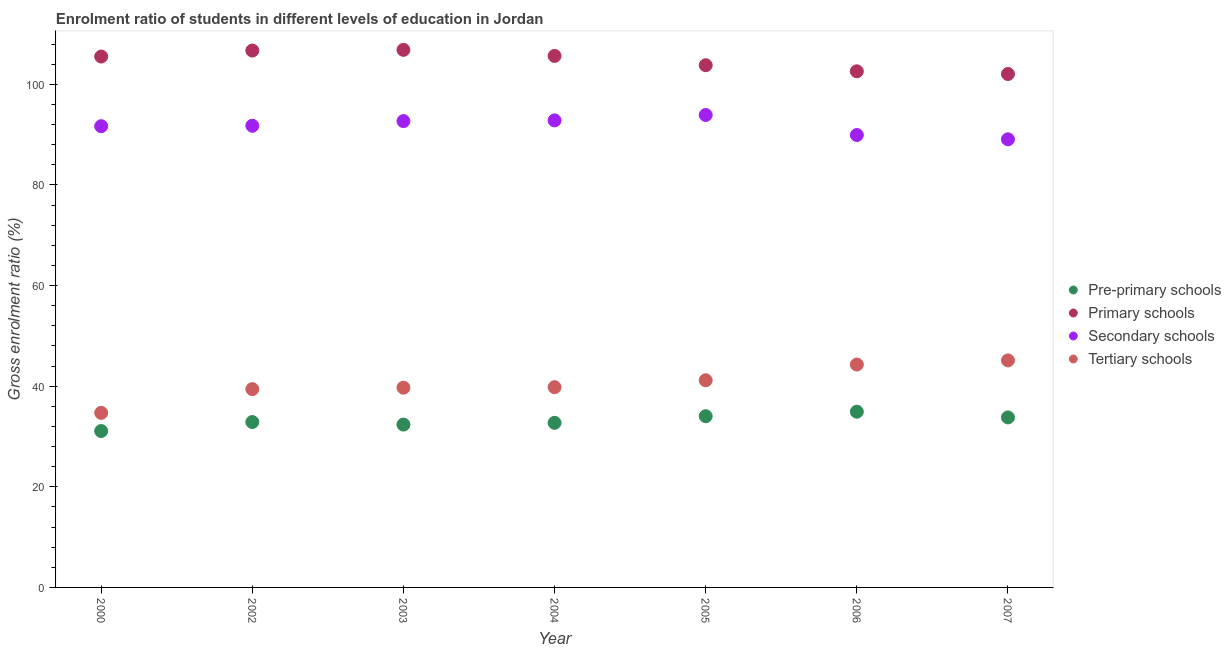How many different coloured dotlines are there?
Your answer should be very brief. 4. Is the number of dotlines equal to the number of legend labels?
Your answer should be compact. Yes. What is the gross enrolment ratio in primary schools in 2003?
Your answer should be compact. 106.83. Across all years, what is the maximum gross enrolment ratio in secondary schools?
Provide a short and direct response. 93.89. Across all years, what is the minimum gross enrolment ratio in secondary schools?
Your answer should be very brief. 89.06. In which year was the gross enrolment ratio in secondary schools maximum?
Provide a succinct answer. 2005. In which year was the gross enrolment ratio in secondary schools minimum?
Give a very brief answer. 2007. What is the total gross enrolment ratio in secondary schools in the graph?
Your response must be concise. 641.78. What is the difference between the gross enrolment ratio in pre-primary schools in 2002 and that in 2007?
Offer a terse response. -0.92. What is the difference between the gross enrolment ratio in tertiary schools in 2003 and the gross enrolment ratio in secondary schools in 2000?
Ensure brevity in your answer.  -51.97. What is the average gross enrolment ratio in pre-primary schools per year?
Keep it short and to the point. 33.11. In the year 2004, what is the difference between the gross enrolment ratio in pre-primary schools and gross enrolment ratio in primary schools?
Give a very brief answer. -72.92. In how many years, is the gross enrolment ratio in primary schools greater than 104 %?
Make the answer very short. 4. What is the ratio of the gross enrolment ratio in secondary schools in 2000 to that in 2007?
Offer a very short reply. 1.03. Is the gross enrolment ratio in primary schools in 2003 less than that in 2007?
Your answer should be very brief. No. Is the difference between the gross enrolment ratio in primary schools in 2000 and 2007 greater than the difference between the gross enrolment ratio in secondary schools in 2000 and 2007?
Offer a terse response. Yes. What is the difference between the highest and the second highest gross enrolment ratio in secondary schools?
Provide a short and direct response. 1.07. What is the difference between the highest and the lowest gross enrolment ratio in pre-primary schools?
Your answer should be very brief. 3.84. In how many years, is the gross enrolment ratio in primary schools greater than the average gross enrolment ratio in primary schools taken over all years?
Your answer should be very brief. 4. Is the sum of the gross enrolment ratio in pre-primary schools in 2003 and 2006 greater than the maximum gross enrolment ratio in secondary schools across all years?
Ensure brevity in your answer.  No. Is it the case that in every year, the sum of the gross enrolment ratio in pre-primary schools and gross enrolment ratio in primary schools is greater than the gross enrolment ratio in secondary schools?
Provide a short and direct response. Yes. Is the gross enrolment ratio in primary schools strictly less than the gross enrolment ratio in pre-primary schools over the years?
Your response must be concise. No. What is the difference between two consecutive major ticks on the Y-axis?
Your response must be concise. 20. Are the values on the major ticks of Y-axis written in scientific E-notation?
Keep it short and to the point. No. Does the graph contain any zero values?
Provide a succinct answer. No. How many legend labels are there?
Give a very brief answer. 4. How are the legend labels stacked?
Your answer should be very brief. Vertical. What is the title of the graph?
Ensure brevity in your answer.  Enrolment ratio of students in different levels of education in Jordan. Does "Agricultural land" appear as one of the legend labels in the graph?
Offer a terse response. No. What is the label or title of the Y-axis?
Give a very brief answer. Gross enrolment ratio (%). What is the Gross enrolment ratio (%) in Pre-primary schools in 2000?
Your response must be concise. 31.08. What is the Gross enrolment ratio (%) of Primary schools in 2000?
Your answer should be very brief. 105.51. What is the Gross enrolment ratio (%) in Secondary schools in 2000?
Keep it short and to the point. 91.67. What is the Gross enrolment ratio (%) of Tertiary schools in 2000?
Your answer should be very brief. 34.69. What is the Gross enrolment ratio (%) in Pre-primary schools in 2002?
Provide a succinct answer. 32.87. What is the Gross enrolment ratio (%) in Primary schools in 2002?
Provide a short and direct response. 106.7. What is the Gross enrolment ratio (%) of Secondary schools in 2002?
Provide a short and direct response. 91.75. What is the Gross enrolment ratio (%) in Tertiary schools in 2002?
Keep it short and to the point. 39.41. What is the Gross enrolment ratio (%) of Pre-primary schools in 2003?
Keep it short and to the point. 32.37. What is the Gross enrolment ratio (%) of Primary schools in 2003?
Offer a very short reply. 106.83. What is the Gross enrolment ratio (%) of Secondary schools in 2003?
Keep it short and to the point. 92.68. What is the Gross enrolment ratio (%) in Tertiary schools in 2003?
Offer a terse response. 39.7. What is the Gross enrolment ratio (%) in Pre-primary schools in 2004?
Ensure brevity in your answer.  32.71. What is the Gross enrolment ratio (%) of Primary schools in 2004?
Ensure brevity in your answer.  105.63. What is the Gross enrolment ratio (%) in Secondary schools in 2004?
Make the answer very short. 92.82. What is the Gross enrolment ratio (%) of Tertiary schools in 2004?
Make the answer very short. 39.8. What is the Gross enrolment ratio (%) in Pre-primary schools in 2005?
Make the answer very short. 34.03. What is the Gross enrolment ratio (%) of Primary schools in 2005?
Make the answer very short. 103.79. What is the Gross enrolment ratio (%) of Secondary schools in 2005?
Give a very brief answer. 93.89. What is the Gross enrolment ratio (%) in Tertiary schools in 2005?
Ensure brevity in your answer.  41.17. What is the Gross enrolment ratio (%) of Pre-primary schools in 2006?
Provide a succinct answer. 34.92. What is the Gross enrolment ratio (%) in Primary schools in 2006?
Provide a succinct answer. 102.57. What is the Gross enrolment ratio (%) of Secondary schools in 2006?
Your answer should be very brief. 89.91. What is the Gross enrolment ratio (%) in Tertiary schools in 2006?
Give a very brief answer. 44.3. What is the Gross enrolment ratio (%) of Pre-primary schools in 2007?
Your response must be concise. 33.78. What is the Gross enrolment ratio (%) in Primary schools in 2007?
Provide a succinct answer. 102.04. What is the Gross enrolment ratio (%) in Secondary schools in 2007?
Provide a succinct answer. 89.06. What is the Gross enrolment ratio (%) in Tertiary schools in 2007?
Your answer should be compact. 45.12. Across all years, what is the maximum Gross enrolment ratio (%) of Pre-primary schools?
Your response must be concise. 34.92. Across all years, what is the maximum Gross enrolment ratio (%) in Primary schools?
Your answer should be very brief. 106.83. Across all years, what is the maximum Gross enrolment ratio (%) in Secondary schools?
Your answer should be compact. 93.89. Across all years, what is the maximum Gross enrolment ratio (%) in Tertiary schools?
Provide a short and direct response. 45.12. Across all years, what is the minimum Gross enrolment ratio (%) in Pre-primary schools?
Give a very brief answer. 31.08. Across all years, what is the minimum Gross enrolment ratio (%) in Primary schools?
Give a very brief answer. 102.04. Across all years, what is the minimum Gross enrolment ratio (%) of Secondary schools?
Offer a terse response. 89.06. Across all years, what is the minimum Gross enrolment ratio (%) in Tertiary schools?
Provide a succinct answer. 34.69. What is the total Gross enrolment ratio (%) of Pre-primary schools in the graph?
Your answer should be very brief. 231.76. What is the total Gross enrolment ratio (%) in Primary schools in the graph?
Provide a succinct answer. 733.08. What is the total Gross enrolment ratio (%) in Secondary schools in the graph?
Give a very brief answer. 641.78. What is the total Gross enrolment ratio (%) in Tertiary schools in the graph?
Provide a succinct answer. 284.19. What is the difference between the Gross enrolment ratio (%) in Pre-primary schools in 2000 and that in 2002?
Provide a short and direct response. -1.79. What is the difference between the Gross enrolment ratio (%) in Primary schools in 2000 and that in 2002?
Ensure brevity in your answer.  -1.19. What is the difference between the Gross enrolment ratio (%) of Secondary schools in 2000 and that in 2002?
Provide a short and direct response. -0.09. What is the difference between the Gross enrolment ratio (%) of Tertiary schools in 2000 and that in 2002?
Offer a very short reply. -4.72. What is the difference between the Gross enrolment ratio (%) in Pre-primary schools in 2000 and that in 2003?
Offer a very short reply. -1.29. What is the difference between the Gross enrolment ratio (%) of Primary schools in 2000 and that in 2003?
Your answer should be very brief. -1.32. What is the difference between the Gross enrolment ratio (%) in Secondary schools in 2000 and that in 2003?
Keep it short and to the point. -1.01. What is the difference between the Gross enrolment ratio (%) of Tertiary schools in 2000 and that in 2003?
Give a very brief answer. -5. What is the difference between the Gross enrolment ratio (%) of Pre-primary schools in 2000 and that in 2004?
Offer a very short reply. -1.63. What is the difference between the Gross enrolment ratio (%) of Primary schools in 2000 and that in 2004?
Keep it short and to the point. -0.12. What is the difference between the Gross enrolment ratio (%) of Secondary schools in 2000 and that in 2004?
Give a very brief answer. -1.15. What is the difference between the Gross enrolment ratio (%) in Tertiary schools in 2000 and that in 2004?
Ensure brevity in your answer.  -5.1. What is the difference between the Gross enrolment ratio (%) in Pre-primary schools in 2000 and that in 2005?
Provide a succinct answer. -2.95. What is the difference between the Gross enrolment ratio (%) of Primary schools in 2000 and that in 2005?
Offer a very short reply. 1.72. What is the difference between the Gross enrolment ratio (%) of Secondary schools in 2000 and that in 2005?
Keep it short and to the point. -2.23. What is the difference between the Gross enrolment ratio (%) in Tertiary schools in 2000 and that in 2005?
Offer a very short reply. -6.47. What is the difference between the Gross enrolment ratio (%) of Pre-primary schools in 2000 and that in 2006?
Provide a short and direct response. -3.84. What is the difference between the Gross enrolment ratio (%) in Primary schools in 2000 and that in 2006?
Make the answer very short. 2.94. What is the difference between the Gross enrolment ratio (%) in Secondary schools in 2000 and that in 2006?
Offer a very short reply. 1.76. What is the difference between the Gross enrolment ratio (%) in Tertiary schools in 2000 and that in 2006?
Provide a succinct answer. -9.61. What is the difference between the Gross enrolment ratio (%) of Pre-primary schools in 2000 and that in 2007?
Your response must be concise. -2.7. What is the difference between the Gross enrolment ratio (%) in Primary schools in 2000 and that in 2007?
Provide a short and direct response. 3.47. What is the difference between the Gross enrolment ratio (%) in Secondary schools in 2000 and that in 2007?
Ensure brevity in your answer.  2.61. What is the difference between the Gross enrolment ratio (%) in Tertiary schools in 2000 and that in 2007?
Keep it short and to the point. -10.43. What is the difference between the Gross enrolment ratio (%) of Pre-primary schools in 2002 and that in 2003?
Keep it short and to the point. 0.5. What is the difference between the Gross enrolment ratio (%) in Primary schools in 2002 and that in 2003?
Give a very brief answer. -0.13. What is the difference between the Gross enrolment ratio (%) in Secondary schools in 2002 and that in 2003?
Ensure brevity in your answer.  -0.93. What is the difference between the Gross enrolment ratio (%) in Tertiary schools in 2002 and that in 2003?
Your response must be concise. -0.28. What is the difference between the Gross enrolment ratio (%) of Pre-primary schools in 2002 and that in 2004?
Offer a very short reply. 0.15. What is the difference between the Gross enrolment ratio (%) of Primary schools in 2002 and that in 2004?
Your response must be concise. 1.07. What is the difference between the Gross enrolment ratio (%) in Secondary schools in 2002 and that in 2004?
Make the answer very short. -1.06. What is the difference between the Gross enrolment ratio (%) in Tertiary schools in 2002 and that in 2004?
Offer a terse response. -0.39. What is the difference between the Gross enrolment ratio (%) in Pre-primary schools in 2002 and that in 2005?
Provide a short and direct response. -1.16. What is the difference between the Gross enrolment ratio (%) of Primary schools in 2002 and that in 2005?
Make the answer very short. 2.91. What is the difference between the Gross enrolment ratio (%) of Secondary schools in 2002 and that in 2005?
Ensure brevity in your answer.  -2.14. What is the difference between the Gross enrolment ratio (%) in Tertiary schools in 2002 and that in 2005?
Give a very brief answer. -1.76. What is the difference between the Gross enrolment ratio (%) of Pre-primary schools in 2002 and that in 2006?
Make the answer very short. -2.06. What is the difference between the Gross enrolment ratio (%) of Primary schools in 2002 and that in 2006?
Offer a very short reply. 4.13. What is the difference between the Gross enrolment ratio (%) in Secondary schools in 2002 and that in 2006?
Provide a short and direct response. 1.84. What is the difference between the Gross enrolment ratio (%) of Tertiary schools in 2002 and that in 2006?
Keep it short and to the point. -4.89. What is the difference between the Gross enrolment ratio (%) of Pre-primary schools in 2002 and that in 2007?
Keep it short and to the point. -0.92. What is the difference between the Gross enrolment ratio (%) in Primary schools in 2002 and that in 2007?
Give a very brief answer. 4.66. What is the difference between the Gross enrolment ratio (%) of Secondary schools in 2002 and that in 2007?
Ensure brevity in your answer.  2.7. What is the difference between the Gross enrolment ratio (%) of Tertiary schools in 2002 and that in 2007?
Offer a terse response. -5.71. What is the difference between the Gross enrolment ratio (%) in Pre-primary schools in 2003 and that in 2004?
Keep it short and to the point. -0.35. What is the difference between the Gross enrolment ratio (%) in Primary schools in 2003 and that in 2004?
Offer a terse response. 1.2. What is the difference between the Gross enrolment ratio (%) of Secondary schools in 2003 and that in 2004?
Your response must be concise. -0.14. What is the difference between the Gross enrolment ratio (%) of Tertiary schools in 2003 and that in 2004?
Make the answer very short. -0.1. What is the difference between the Gross enrolment ratio (%) in Pre-primary schools in 2003 and that in 2005?
Your response must be concise. -1.67. What is the difference between the Gross enrolment ratio (%) of Primary schools in 2003 and that in 2005?
Provide a short and direct response. 3.05. What is the difference between the Gross enrolment ratio (%) of Secondary schools in 2003 and that in 2005?
Offer a very short reply. -1.21. What is the difference between the Gross enrolment ratio (%) in Tertiary schools in 2003 and that in 2005?
Offer a terse response. -1.47. What is the difference between the Gross enrolment ratio (%) of Pre-primary schools in 2003 and that in 2006?
Give a very brief answer. -2.56. What is the difference between the Gross enrolment ratio (%) of Primary schools in 2003 and that in 2006?
Your answer should be very brief. 4.26. What is the difference between the Gross enrolment ratio (%) in Secondary schools in 2003 and that in 2006?
Provide a succinct answer. 2.77. What is the difference between the Gross enrolment ratio (%) of Tertiary schools in 2003 and that in 2006?
Your response must be concise. -4.6. What is the difference between the Gross enrolment ratio (%) of Pre-primary schools in 2003 and that in 2007?
Ensure brevity in your answer.  -1.42. What is the difference between the Gross enrolment ratio (%) of Primary schools in 2003 and that in 2007?
Keep it short and to the point. 4.79. What is the difference between the Gross enrolment ratio (%) of Secondary schools in 2003 and that in 2007?
Provide a succinct answer. 3.62. What is the difference between the Gross enrolment ratio (%) of Tertiary schools in 2003 and that in 2007?
Ensure brevity in your answer.  -5.42. What is the difference between the Gross enrolment ratio (%) of Pre-primary schools in 2004 and that in 2005?
Keep it short and to the point. -1.32. What is the difference between the Gross enrolment ratio (%) of Primary schools in 2004 and that in 2005?
Your answer should be very brief. 1.85. What is the difference between the Gross enrolment ratio (%) of Secondary schools in 2004 and that in 2005?
Offer a terse response. -1.07. What is the difference between the Gross enrolment ratio (%) of Tertiary schools in 2004 and that in 2005?
Your response must be concise. -1.37. What is the difference between the Gross enrolment ratio (%) of Pre-primary schools in 2004 and that in 2006?
Offer a very short reply. -2.21. What is the difference between the Gross enrolment ratio (%) of Primary schools in 2004 and that in 2006?
Offer a terse response. 3.06. What is the difference between the Gross enrolment ratio (%) of Secondary schools in 2004 and that in 2006?
Offer a terse response. 2.91. What is the difference between the Gross enrolment ratio (%) in Tertiary schools in 2004 and that in 2006?
Offer a terse response. -4.5. What is the difference between the Gross enrolment ratio (%) of Pre-primary schools in 2004 and that in 2007?
Give a very brief answer. -1.07. What is the difference between the Gross enrolment ratio (%) in Primary schools in 2004 and that in 2007?
Offer a very short reply. 3.59. What is the difference between the Gross enrolment ratio (%) in Secondary schools in 2004 and that in 2007?
Provide a short and direct response. 3.76. What is the difference between the Gross enrolment ratio (%) in Tertiary schools in 2004 and that in 2007?
Offer a very short reply. -5.32. What is the difference between the Gross enrolment ratio (%) of Pre-primary schools in 2005 and that in 2006?
Offer a terse response. -0.89. What is the difference between the Gross enrolment ratio (%) of Primary schools in 2005 and that in 2006?
Your answer should be compact. 1.21. What is the difference between the Gross enrolment ratio (%) in Secondary schools in 2005 and that in 2006?
Give a very brief answer. 3.98. What is the difference between the Gross enrolment ratio (%) in Tertiary schools in 2005 and that in 2006?
Ensure brevity in your answer.  -3.13. What is the difference between the Gross enrolment ratio (%) of Pre-primary schools in 2005 and that in 2007?
Give a very brief answer. 0.25. What is the difference between the Gross enrolment ratio (%) in Primary schools in 2005 and that in 2007?
Offer a very short reply. 1.75. What is the difference between the Gross enrolment ratio (%) of Secondary schools in 2005 and that in 2007?
Provide a short and direct response. 4.83. What is the difference between the Gross enrolment ratio (%) in Tertiary schools in 2005 and that in 2007?
Keep it short and to the point. -3.95. What is the difference between the Gross enrolment ratio (%) of Pre-primary schools in 2006 and that in 2007?
Ensure brevity in your answer.  1.14. What is the difference between the Gross enrolment ratio (%) in Primary schools in 2006 and that in 2007?
Offer a terse response. 0.53. What is the difference between the Gross enrolment ratio (%) in Secondary schools in 2006 and that in 2007?
Offer a terse response. 0.85. What is the difference between the Gross enrolment ratio (%) of Tertiary schools in 2006 and that in 2007?
Your response must be concise. -0.82. What is the difference between the Gross enrolment ratio (%) of Pre-primary schools in 2000 and the Gross enrolment ratio (%) of Primary schools in 2002?
Ensure brevity in your answer.  -75.62. What is the difference between the Gross enrolment ratio (%) in Pre-primary schools in 2000 and the Gross enrolment ratio (%) in Secondary schools in 2002?
Offer a terse response. -60.67. What is the difference between the Gross enrolment ratio (%) of Pre-primary schools in 2000 and the Gross enrolment ratio (%) of Tertiary schools in 2002?
Offer a terse response. -8.33. What is the difference between the Gross enrolment ratio (%) in Primary schools in 2000 and the Gross enrolment ratio (%) in Secondary schools in 2002?
Provide a succinct answer. 13.76. What is the difference between the Gross enrolment ratio (%) in Primary schools in 2000 and the Gross enrolment ratio (%) in Tertiary schools in 2002?
Your answer should be very brief. 66.1. What is the difference between the Gross enrolment ratio (%) of Secondary schools in 2000 and the Gross enrolment ratio (%) of Tertiary schools in 2002?
Give a very brief answer. 52.25. What is the difference between the Gross enrolment ratio (%) of Pre-primary schools in 2000 and the Gross enrolment ratio (%) of Primary schools in 2003?
Keep it short and to the point. -75.75. What is the difference between the Gross enrolment ratio (%) in Pre-primary schools in 2000 and the Gross enrolment ratio (%) in Secondary schools in 2003?
Offer a terse response. -61.6. What is the difference between the Gross enrolment ratio (%) in Pre-primary schools in 2000 and the Gross enrolment ratio (%) in Tertiary schools in 2003?
Provide a succinct answer. -8.62. What is the difference between the Gross enrolment ratio (%) in Primary schools in 2000 and the Gross enrolment ratio (%) in Secondary schools in 2003?
Provide a short and direct response. 12.83. What is the difference between the Gross enrolment ratio (%) in Primary schools in 2000 and the Gross enrolment ratio (%) in Tertiary schools in 2003?
Provide a short and direct response. 65.81. What is the difference between the Gross enrolment ratio (%) of Secondary schools in 2000 and the Gross enrolment ratio (%) of Tertiary schools in 2003?
Offer a terse response. 51.97. What is the difference between the Gross enrolment ratio (%) in Pre-primary schools in 2000 and the Gross enrolment ratio (%) in Primary schools in 2004?
Keep it short and to the point. -74.55. What is the difference between the Gross enrolment ratio (%) in Pre-primary schools in 2000 and the Gross enrolment ratio (%) in Secondary schools in 2004?
Your answer should be compact. -61.74. What is the difference between the Gross enrolment ratio (%) of Pre-primary schools in 2000 and the Gross enrolment ratio (%) of Tertiary schools in 2004?
Offer a terse response. -8.72. What is the difference between the Gross enrolment ratio (%) of Primary schools in 2000 and the Gross enrolment ratio (%) of Secondary schools in 2004?
Your answer should be compact. 12.69. What is the difference between the Gross enrolment ratio (%) in Primary schools in 2000 and the Gross enrolment ratio (%) in Tertiary schools in 2004?
Ensure brevity in your answer.  65.71. What is the difference between the Gross enrolment ratio (%) in Secondary schools in 2000 and the Gross enrolment ratio (%) in Tertiary schools in 2004?
Give a very brief answer. 51.87. What is the difference between the Gross enrolment ratio (%) of Pre-primary schools in 2000 and the Gross enrolment ratio (%) of Primary schools in 2005?
Keep it short and to the point. -72.71. What is the difference between the Gross enrolment ratio (%) of Pre-primary schools in 2000 and the Gross enrolment ratio (%) of Secondary schools in 2005?
Offer a terse response. -62.81. What is the difference between the Gross enrolment ratio (%) in Pre-primary schools in 2000 and the Gross enrolment ratio (%) in Tertiary schools in 2005?
Your response must be concise. -10.09. What is the difference between the Gross enrolment ratio (%) in Primary schools in 2000 and the Gross enrolment ratio (%) in Secondary schools in 2005?
Provide a succinct answer. 11.62. What is the difference between the Gross enrolment ratio (%) of Primary schools in 2000 and the Gross enrolment ratio (%) of Tertiary schools in 2005?
Provide a short and direct response. 64.34. What is the difference between the Gross enrolment ratio (%) in Secondary schools in 2000 and the Gross enrolment ratio (%) in Tertiary schools in 2005?
Make the answer very short. 50.5. What is the difference between the Gross enrolment ratio (%) in Pre-primary schools in 2000 and the Gross enrolment ratio (%) in Primary schools in 2006?
Make the answer very short. -71.49. What is the difference between the Gross enrolment ratio (%) in Pre-primary schools in 2000 and the Gross enrolment ratio (%) in Secondary schools in 2006?
Your answer should be very brief. -58.83. What is the difference between the Gross enrolment ratio (%) in Pre-primary schools in 2000 and the Gross enrolment ratio (%) in Tertiary schools in 2006?
Provide a succinct answer. -13.22. What is the difference between the Gross enrolment ratio (%) of Primary schools in 2000 and the Gross enrolment ratio (%) of Secondary schools in 2006?
Make the answer very short. 15.6. What is the difference between the Gross enrolment ratio (%) in Primary schools in 2000 and the Gross enrolment ratio (%) in Tertiary schools in 2006?
Your response must be concise. 61.21. What is the difference between the Gross enrolment ratio (%) in Secondary schools in 2000 and the Gross enrolment ratio (%) in Tertiary schools in 2006?
Make the answer very short. 47.37. What is the difference between the Gross enrolment ratio (%) in Pre-primary schools in 2000 and the Gross enrolment ratio (%) in Primary schools in 2007?
Your response must be concise. -70.96. What is the difference between the Gross enrolment ratio (%) of Pre-primary schools in 2000 and the Gross enrolment ratio (%) of Secondary schools in 2007?
Make the answer very short. -57.98. What is the difference between the Gross enrolment ratio (%) of Pre-primary schools in 2000 and the Gross enrolment ratio (%) of Tertiary schools in 2007?
Your answer should be compact. -14.04. What is the difference between the Gross enrolment ratio (%) of Primary schools in 2000 and the Gross enrolment ratio (%) of Secondary schools in 2007?
Offer a terse response. 16.45. What is the difference between the Gross enrolment ratio (%) of Primary schools in 2000 and the Gross enrolment ratio (%) of Tertiary schools in 2007?
Your answer should be very brief. 60.39. What is the difference between the Gross enrolment ratio (%) in Secondary schools in 2000 and the Gross enrolment ratio (%) in Tertiary schools in 2007?
Ensure brevity in your answer.  46.55. What is the difference between the Gross enrolment ratio (%) in Pre-primary schools in 2002 and the Gross enrolment ratio (%) in Primary schools in 2003?
Your answer should be very brief. -73.97. What is the difference between the Gross enrolment ratio (%) in Pre-primary schools in 2002 and the Gross enrolment ratio (%) in Secondary schools in 2003?
Provide a succinct answer. -59.81. What is the difference between the Gross enrolment ratio (%) in Pre-primary schools in 2002 and the Gross enrolment ratio (%) in Tertiary schools in 2003?
Provide a short and direct response. -6.83. What is the difference between the Gross enrolment ratio (%) of Primary schools in 2002 and the Gross enrolment ratio (%) of Secondary schools in 2003?
Keep it short and to the point. 14.02. What is the difference between the Gross enrolment ratio (%) of Primary schools in 2002 and the Gross enrolment ratio (%) of Tertiary schools in 2003?
Give a very brief answer. 67. What is the difference between the Gross enrolment ratio (%) of Secondary schools in 2002 and the Gross enrolment ratio (%) of Tertiary schools in 2003?
Make the answer very short. 52.06. What is the difference between the Gross enrolment ratio (%) of Pre-primary schools in 2002 and the Gross enrolment ratio (%) of Primary schools in 2004?
Your answer should be very brief. -72.77. What is the difference between the Gross enrolment ratio (%) of Pre-primary schools in 2002 and the Gross enrolment ratio (%) of Secondary schools in 2004?
Offer a very short reply. -59.95. What is the difference between the Gross enrolment ratio (%) of Pre-primary schools in 2002 and the Gross enrolment ratio (%) of Tertiary schools in 2004?
Your answer should be very brief. -6.93. What is the difference between the Gross enrolment ratio (%) of Primary schools in 2002 and the Gross enrolment ratio (%) of Secondary schools in 2004?
Provide a succinct answer. 13.88. What is the difference between the Gross enrolment ratio (%) of Primary schools in 2002 and the Gross enrolment ratio (%) of Tertiary schools in 2004?
Provide a short and direct response. 66.9. What is the difference between the Gross enrolment ratio (%) in Secondary schools in 2002 and the Gross enrolment ratio (%) in Tertiary schools in 2004?
Keep it short and to the point. 51.96. What is the difference between the Gross enrolment ratio (%) of Pre-primary schools in 2002 and the Gross enrolment ratio (%) of Primary schools in 2005?
Your answer should be compact. -70.92. What is the difference between the Gross enrolment ratio (%) in Pre-primary schools in 2002 and the Gross enrolment ratio (%) in Secondary schools in 2005?
Give a very brief answer. -61.03. What is the difference between the Gross enrolment ratio (%) of Pre-primary schools in 2002 and the Gross enrolment ratio (%) of Tertiary schools in 2005?
Offer a terse response. -8.3. What is the difference between the Gross enrolment ratio (%) in Primary schools in 2002 and the Gross enrolment ratio (%) in Secondary schools in 2005?
Give a very brief answer. 12.81. What is the difference between the Gross enrolment ratio (%) in Primary schools in 2002 and the Gross enrolment ratio (%) in Tertiary schools in 2005?
Your answer should be very brief. 65.53. What is the difference between the Gross enrolment ratio (%) of Secondary schools in 2002 and the Gross enrolment ratio (%) of Tertiary schools in 2005?
Give a very brief answer. 50.59. What is the difference between the Gross enrolment ratio (%) in Pre-primary schools in 2002 and the Gross enrolment ratio (%) in Primary schools in 2006?
Keep it short and to the point. -69.71. What is the difference between the Gross enrolment ratio (%) in Pre-primary schools in 2002 and the Gross enrolment ratio (%) in Secondary schools in 2006?
Make the answer very short. -57.04. What is the difference between the Gross enrolment ratio (%) in Pre-primary schools in 2002 and the Gross enrolment ratio (%) in Tertiary schools in 2006?
Offer a terse response. -11.43. What is the difference between the Gross enrolment ratio (%) in Primary schools in 2002 and the Gross enrolment ratio (%) in Secondary schools in 2006?
Provide a succinct answer. 16.79. What is the difference between the Gross enrolment ratio (%) of Primary schools in 2002 and the Gross enrolment ratio (%) of Tertiary schools in 2006?
Give a very brief answer. 62.4. What is the difference between the Gross enrolment ratio (%) in Secondary schools in 2002 and the Gross enrolment ratio (%) in Tertiary schools in 2006?
Ensure brevity in your answer.  47.45. What is the difference between the Gross enrolment ratio (%) in Pre-primary schools in 2002 and the Gross enrolment ratio (%) in Primary schools in 2007?
Make the answer very short. -69.17. What is the difference between the Gross enrolment ratio (%) of Pre-primary schools in 2002 and the Gross enrolment ratio (%) of Secondary schools in 2007?
Your answer should be very brief. -56.19. What is the difference between the Gross enrolment ratio (%) in Pre-primary schools in 2002 and the Gross enrolment ratio (%) in Tertiary schools in 2007?
Keep it short and to the point. -12.25. What is the difference between the Gross enrolment ratio (%) of Primary schools in 2002 and the Gross enrolment ratio (%) of Secondary schools in 2007?
Your answer should be very brief. 17.64. What is the difference between the Gross enrolment ratio (%) of Primary schools in 2002 and the Gross enrolment ratio (%) of Tertiary schools in 2007?
Make the answer very short. 61.58. What is the difference between the Gross enrolment ratio (%) of Secondary schools in 2002 and the Gross enrolment ratio (%) of Tertiary schools in 2007?
Give a very brief answer. 46.63. What is the difference between the Gross enrolment ratio (%) of Pre-primary schools in 2003 and the Gross enrolment ratio (%) of Primary schools in 2004?
Ensure brevity in your answer.  -73.27. What is the difference between the Gross enrolment ratio (%) of Pre-primary schools in 2003 and the Gross enrolment ratio (%) of Secondary schools in 2004?
Offer a terse response. -60.45. What is the difference between the Gross enrolment ratio (%) of Pre-primary schools in 2003 and the Gross enrolment ratio (%) of Tertiary schools in 2004?
Give a very brief answer. -7.43. What is the difference between the Gross enrolment ratio (%) of Primary schools in 2003 and the Gross enrolment ratio (%) of Secondary schools in 2004?
Provide a short and direct response. 14.01. What is the difference between the Gross enrolment ratio (%) in Primary schools in 2003 and the Gross enrolment ratio (%) in Tertiary schools in 2004?
Keep it short and to the point. 67.04. What is the difference between the Gross enrolment ratio (%) in Secondary schools in 2003 and the Gross enrolment ratio (%) in Tertiary schools in 2004?
Keep it short and to the point. 52.88. What is the difference between the Gross enrolment ratio (%) in Pre-primary schools in 2003 and the Gross enrolment ratio (%) in Primary schools in 2005?
Provide a short and direct response. -71.42. What is the difference between the Gross enrolment ratio (%) in Pre-primary schools in 2003 and the Gross enrolment ratio (%) in Secondary schools in 2005?
Keep it short and to the point. -61.53. What is the difference between the Gross enrolment ratio (%) in Pre-primary schools in 2003 and the Gross enrolment ratio (%) in Tertiary schools in 2005?
Make the answer very short. -8.8. What is the difference between the Gross enrolment ratio (%) of Primary schools in 2003 and the Gross enrolment ratio (%) of Secondary schools in 2005?
Your answer should be compact. 12.94. What is the difference between the Gross enrolment ratio (%) in Primary schools in 2003 and the Gross enrolment ratio (%) in Tertiary schools in 2005?
Offer a terse response. 65.66. What is the difference between the Gross enrolment ratio (%) in Secondary schools in 2003 and the Gross enrolment ratio (%) in Tertiary schools in 2005?
Offer a terse response. 51.51. What is the difference between the Gross enrolment ratio (%) of Pre-primary schools in 2003 and the Gross enrolment ratio (%) of Primary schools in 2006?
Your answer should be compact. -70.21. What is the difference between the Gross enrolment ratio (%) in Pre-primary schools in 2003 and the Gross enrolment ratio (%) in Secondary schools in 2006?
Your response must be concise. -57.55. What is the difference between the Gross enrolment ratio (%) of Pre-primary schools in 2003 and the Gross enrolment ratio (%) of Tertiary schools in 2006?
Your response must be concise. -11.94. What is the difference between the Gross enrolment ratio (%) in Primary schools in 2003 and the Gross enrolment ratio (%) in Secondary schools in 2006?
Offer a terse response. 16.92. What is the difference between the Gross enrolment ratio (%) of Primary schools in 2003 and the Gross enrolment ratio (%) of Tertiary schools in 2006?
Ensure brevity in your answer.  62.53. What is the difference between the Gross enrolment ratio (%) in Secondary schools in 2003 and the Gross enrolment ratio (%) in Tertiary schools in 2006?
Your answer should be compact. 48.38. What is the difference between the Gross enrolment ratio (%) of Pre-primary schools in 2003 and the Gross enrolment ratio (%) of Primary schools in 2007?
Make the answer very short. -69.67. What is the difference between the Gross enrolment ratio (%) of Pre-primary schools in 2003 and the Gross enrolment ratio (%) of Secondary schools in 2007?
Ensure brevity in your answer.  -56.69. What is the difference between the Gross enrolment ratio (%) of Pre-primary schools in 2003 and the Gross enrolment ratio (%) of Tertiary schools in 2007?
Make the answer very short. -12.75. What is the difference between the Gross enrolment ratio (%) in Primary schools in 2003 and the Gross enrolment ratio (%) in Secondary schools in 2007?
Offer a terse response. 17.77. What is the difference between the Gross enrolment ratio (%) of Primary schools in 2003 and the Gross enrolment ratio (%) of Tertiary schools in 2007?
Keep it short and to the point. 61.71. What is the difference between the Gross enrolment ratio (%) in Secondary schools in 2003 and the Gross enrolment ratio (%) in Tertiary schools in 2007?
Offer a very short reply. 47.56. What is the difference between the Gross enrolment ratio (%) of Pre-primary schools in 2004 and the Gross enrolment ratio (%) of Primary schools in 2005?
Keep it short and to the point. -71.07. What is the difference between the Gross enrolment ratio (%) in Pre-primary schools in 2004 and the Gross enrolment ratio (%) in Secondary schools in 2005?
Ensure brevity in your answer.  -61.18. What is the difference between the Gross enrolment ratio (%) in Pre-primary schools in 2004 and the Gross enrolment ratio (%) in Tertiary schools in 2005?
Offer a very short reply. -8.46. What is the difference between the Gross enrolment ratio (%) of Primary schools in 2004 and the Gross enrolment ratio (%) of Secondary schools in 2005?
Ensure brevity in your answer.  11.74. What is the difference between the Gross enrolment ratio (%) of Primary schools in 2004 and the Gross enrolment ratio (%) of Tertiary schools in 2005?
Offer a very short reply. 64.47. What is the difference between the Gross enrolment ratio (%) of Secondary schools in 2004 and the Gross enrolment ratio (%) of Tertiary schools in 2005?
Keep it short and to the point. 51.65. What is the difference between the Gross enrolment ratio (%) of Pre-primary schools in 2004 and the Gross enrolment ratio (%) of Primary schools in 2006?
Provide a short and direct response. -69.86. What is the difference between the Gross enrolment ratio (%) in Pre-primary schools in 2004 and the Gross enrolment ratio (%) in Secondary schools in 2006?
Make the answer very short. -57.2. What is the difference between the Gross enrolment ratio (%) of Pre-primary schools in 2004 and the Gross enrolment ratio (%) of Tertiary schools in 2006?
Offer a very short reply. -11.59. What is the difference between the Gross enrolment ratio (%) in Primary schools in 2004 and the Gross enrolment ratio (%) in Secondary schools in 2006?
Provide a succinct answer. 15.72. What is the difference between the Gross enrolment ratio (%) in Primary schools in 2004 and the Gross enrolment ratio (%) in Tertiary schools in 2006?
Your response must be concise. 61.33. What is the difference between the Gross enrolment ratio (%) of Secondary schools in 2004 and the Gross enrolment ratio (%) of Tertiary schools in 2006?
Keep it short and to the point. 48.52. What is the difference between the Gross enrolment ratio (%) in Pre-primary schools in 2004 and the Gross enrolment ratio (%) in Primary schools in 2007?
Your answer should be compact. -69.33. What is the difference between the Gross enrolment ratio (%) of Pre-primary schools in 2004 and the Gross enrolment ratio (%) of Secondary schools in 2007?
Your answer should be very brief. -56.35. What is the difference between the Gross enrolment ratio (%) of Pre-primary schools in 2004 and the Gross enrolment ratio (%) of Tertiary schools in 2007?
Offer a terse response. -12.41. What is the difference between the Gross enrolment ratio (%) of Primary schools in 2004 and the Gross enrolment ratio (%) of Secondary schools in 2007?
Keep it short and to the point. 16.58. What is the difference between the Gross enrolment ratio (%) in Primary schools in 2004 and the Gross enrolment ratio (%) in Tertiary schools in 2007?
Make the answer very short. 60.51. What is the difference between the Gross enrolment ratio (%) of Secondary schools in 2004 and the Gross enrolment ratio (%) of Tertiary schools in 2007?
Offer a very short reply. 47.7. What is the difference between the Gross enrolment ratio (%) in Pre-primary schools in 2005 and the Gross enrolment ratio (%) in Primary schools in 2006?
Your response must be concise. -68.54. What is the difference between the Gross enrolment ratio (%) of Pre-primary schools in 2005 and the Gross enrolment ratio (%) of Secondary schools in 2006?
Ensure brevity in your answer.  -55.88. What is the difference between the Gross enrolment ratio (%) of Pre-primary schools in 2005 and the Gross enrolment ratio (%) of Tertiary schools in 2006?
Your answer should be very brief. -10.27. What is the difference between the Gross enrolment ratio (%) of Primary schools in 2005 and the Gross enrolment ratio (%) of Secondary schools in 2006?
Your response must be concise. 13.88. What is the difference between the Gross enrolment ratio (%) in Primary schools in 2005 and the Gross enrolment ratio (%) in Tertiary schools in 2006?
Ensure brevity in your answer.  59.49. What is the difference between the Gross enrolment ratio (%) of Secondary schools in 2005 and the Gross enrolment ratio (%) of Tertiary schools in 2006?
Your answer should be compact. 49.59. What is the difference between the Gross enrolment ratio (%) of Pre-primary schools in 2005 and the Gross enrolment ratio (%) of Primary schools in 2007?
Provide a succinct answer. -68.01. What is the difference between the Gross enrolment ratio (%) in Pre-primary schools in 2005 and the Gross enrolment ratio (%) in Secondary schools in 2007?
Your answer should be compact. -55.03. What is the difference between the Gross enrolment ratio (%) of Pre-primary schools in 2005 and the Gross enrolment ratio (%) of Tertiary schools in 2007?
Your answer should be compact. -11.09. What is the difference between the Gross enrolment ratio (%) in Primary schools in 2005 and the Gross enrolment ratio (%) in Secondary schools in 2007?
Keep it short and to the point. 14.73. What is the difference between the Gross enrolment ratio (%) of Primary schools in 2005 and the Gross enrolment ratio (%) of Tertiary schools in 2007?
Ensure brevity in your answer.  58.67. What is the difference between the Gross enrolment ratio (%) in Secondary schools in 2005 and the Gross enrolment ratio (%) in Tertiary schools in 2007?
Make the answer very short. 48.77. What is the difference between the Gross enrolment ratio (%) in Pre-primary schools in 2006 and the Gross enrolment ratio (%) in Primary schools in 2007?
Keep it short and to the point. -67.12. What is the difference between the Gross enrolment ratio (%) of Pre-primary schools in 2006 and the Gross enrolment ratio (%) of Secondary schools in 2007?
Provide a short and direct response. -54.14. What is the difference between the Gross enrolment ratio (%) in Pre-primary schools in 2006 and the Gross enrolment ratio (%) in Tertiary schools in 2007?
Provide a short and direct response. -10.2. What is the difference between the Gross enrolment ratio (%) of Primary schools in 2006 and the Gross enrolment ratio (%) of Secondary schools in 2007?
Offer a very short reply. 13.52. What is the difference between the Gross enrolment ratio (%) in Primary schools in 2006 and the Gross enrolment ratio (%) in Tertiary schools in 2007?
Your answer should be compact. 57.45. What is the difference between the Gross enrolment ratio (%) of Secondary schools in 2006 and the Gross enrolment ratio (%) of Tertiary schools in 2007?
Offer a very short reply. 44.79. What is the average Gross enrolment ratio (%) of Pre-primary schools per year?
Ensure brevity in your answer.  33.11. What is the average Gross enrolment ratio (%) of Primary schools per year?
Your answer should be very brief. 104.73. What is the average Gross enrolment ratio (%) of Secondary schools per year?
Your answer should be very brief. 91.68. What is the average Gross enrolment ratio (%) of Tertiary schools per year?
Offer a terse response. 40.6. In the year 2000, what is the difference between the Gross enrolment ratio (%) of Pre-primary schools and Gross enrolment ratio (%) of Primary schools?
Keep it short and to the point. -74.43. In the year 2000, what is the difference between the Gross enrolment ratio (%) of Pre-primary schools and Gross enrolment ratio (%) of Secondary schools?
Your answer should be very brief. -60.59. In the year 2000, what is the difference between the Gross enrolment ratio (%) in Pre-primary schools and Gross enrolment ratio (%) in Tertiary schools?
Provide a succinct answer. -3.61. In the year 2000, what is the difference between the Gross enrolment ratio (%) of Primary schools and Gross enrolment ratio (%) of Secondary schools?
Offer a terse response. 13.84. In the year 2000, what is the difference between the Gross enrolment ratio (%) in Primary schools and Gross enrolment ratio (%) in Tertiary schools?
Ensure brevity in your answer.  70.82. In the year 2000, what is the difference between the Gross enrolment ratio (%) in Secondary schools and Gross enrolment ratio (%) in Tertiary schools?
Provide a short and direct response. 56.97. In the year 2002, what is the difference between the Gross enrolment ratio (%) of Pre-primary schools and Gross enrolment ratio (%) of Primary schools?
Offer a terse response. -73.83. In the year 2002, what is the difference between the Gross enrolment ratio (%) of Pre-primary schools and Gross enrolment ratio (%) of Secondary schools?
Your answer should be compact. -58.89. In the year 2002, what is the difference between the Gross enrolment ratio (%) of Pre-primary schools and Gross enrolment ratio (%) of Tertiary schools?
Provide a short and direct response. -6.54. In the year 2002, what is the difference between the Gross enrolment ratio (%) in Primary schools and Gross enrolment ratio (%) in Secondary schools?
Provide a short and direct response. 14.95. In the year 2002, what is the difference between the Gross enrolment ratio (%) of Primary schools and Gross enrolment ratio (%) of Tertiary schools?
Ensure brevity in your answer.  67.29. In the year 2002, what is the difference between the Gross enrolment ratio (%) in Secondary schools and Gross enrolment ratio (%) in Tertiary schools?
Give a very brief answer. 52.34. In the year 2003, what is the difference between the Gross enrolment ratio (%) in Pre-primary schools and Gross enrolment ratio (%) in Primary schools?
Ensure brevity in your answer.  -74.47. In the year 2003, what is the difference between the Gross enrolment ratio (%) in Pre-primary schools and Gross enrolment ratio (%) in Secondary schools?
Make the answer very short. -60.31. In the year 2003, what is the difference between the Gross enrolment ratio (%) in Pre-primary schools and Gross enrolment ratio (%) in Tertiary schools?
Offer a very short reply. -7.33. In the year 2003, what is the difference between the Gross enrolment ratio (%) in Primary schools and Gross enrolment ratio (%) in Secondary schools?
Your answer should be very brief. 14.15. In the year 2003, what is the difference between the Gross enrolment ratio (%) of Primary schools and Gross enrolment ratio (%) of Tertiary schools?
Offer a terse response. 67.14. In the year 2003, what is the difference between the Gross enrolment ratio (%) of Secondary schools and Gross enrolment ratio (%) of Tertiary schools?
Provide a short and direct response. 52.98. In the year 2004, what is the difference between the Gross enrolment ratio (%) in Pre-primary schools and Gross enrolment ratio (%) in Primary schools?
Provide a short and direct response. -72.92. In the year 2004, what is the difference between the Gross enrolment ratio (%) of Pre-primary schools and Gross enrolment ratio (%) of Secondary schools?
Offer a very short reply. -60.11. In the year 2004, what is the difference between the Gross enrolment ratio (%) of Pre-primary schools and Gross enrolment ratio (%) of Tertiary schools?
Give a very brief answer. -7.08. In the year 2004, what is the difference between the Gross enrolment ratio (%) of Primary schools and Gross enrolment ratio (%) of Secondary schools?
Ensure brevity in your answer.  12.82. In the year 2004, what is the difference between the Gross enrolment ratio (%) in Primary schools and Gross enrolment ratio (%) in Tertiary schools?
Provide a short and direct response. 65.84. In the year 2004, what is the difference between the Gross enrolment ratio (%) of Secondary schools and Gross enrolment ratio (%) of Tertiary schools?
Keep it short and to the point. 53.02. In the year 2005, what is the difference between the Gross enrolment ratio (%) in Pre-primary schools and Gross enrolment ratio (%) in Primary schools?
Ensure brevity in your answer.  -69.75. In the year 2005, what is the difference between the Gross enrolment ratio (%) of Pre-primary schools and Gross enrolment ratio (%) of Secondary schools?
Your answer should be compact. -59.86. In the year 2005, what is the difference between the Gross enrolment ratio (%) in Pre-primary schools and Gross enrolment ratio (%) in Tertiary schools?
Your answer should be compact. -7.14. In the year 2005, what is the difference between the Gross enrolment ratio (%) of Primary schools and Gross enrolment ratio (%) of Secondary schools?
Your answer should be compact. 9.89. In the year 2005, what is the difference between the Gross enrolment ratio (%) in Primary schools and Gross enrolment ratio (%) in Tertiary schools?
Provide a succinct answer. 62.62. In the year 2005, what is the difference between the Gross enrolment ratio (%) of Secondary schools and Gross enrolment ratio (%) of Tertiary schools?
Offer a terse response. 52.72. In the year 2006, what is the difference between the Gross enrolment ratio (%) in Pre-primary schools and Gross enrolment ratio (%) in Primary schools?
Your answer should be very brief. -67.65. In the year 2006, what is the difference between the Gross enrolment ratio (%) in Pre-primary schools and Gross enrolment ratio (%) in Secondary schools?
Your answer should be very brief. -54.99. In the year 2006, what is the difference between the Gross enrolment ratio (%) in Pre-primary schools and Gross enrolment ratio (%) in Tertiary schools?
Provide a succinct answer. -9.38. In the year 2006, what is the difference between the Gross enrolment ratio (%) in Primary schools and Gross enrolment ratio (%) in Secondary schools?
Keep it short and to the point. 12.66. In the year 2006, what is the difference between the Gross enrolment ratio (%) in Primary schools and Gross enrolment ratio (%) in Tertiary schools?
Your answer should be very brief. 58.27. In the year 2006, what is the difference between the Gross enrolment ratio (%) of Secondary schools and Gross enrolment ratio (%) of Tertiary schools?
Keep it short and to the point. 45.61. In the year 2007, what is the difference between the Gross enrolment ratio (%) of Pre-primary schools and Gross enrolment ratio (%) of Primary schools?
Provide a short and direct response. -68.26. In the year 2007, what is the difference between the Gross enrolment ratio (%) of Pre-primary schools and Gross enrolment ratio (%) of Secondary schools?
Ensure brevity in your answer.  -55.27. In the year 2007, what is the difference between the Gross enrolment ratio (%) in Pre-primary schools and Gross enrolment ratio (%) in Tertiary schools?
Make the answer very short. -11.33. In the year 2007, what is the difference between the Gross enrolment ratio (%) in Primary schools and Gross enrolment ratio (%) in Secondary schools?
Keep it short and to the point. 12.98. In the year 2007, what is the difference between the Gross enrolment ratio (%) in Primary schools and Gross enrolment ratio (%) in Tertiary schools?
Your answer should be compact. 56.92. In the year 2007, what is the difference between the Gross enrolment ratio (%) of Secondary schools and Gross enrolment ratio (%) of Tertiary schools?
Your answer should be compact. 43.94. What is the ratio of the Gross enrolment ratio (%) of Pre-primary schools in 2000 to that in 2002?
Ensure brevity in your answer.  0.95. What is the ratio of the Gross enrolment ratio (%) in Primary schools in 2000 to that in 2002?
Offer a very short reply. 0.99. What is the ratio of the Gross enrolment ratio (%) of Secondary schools in 2000 to that in 2002?
Give a very brief answer. 1. What is the ratio of the Gross enrolment ratio (%) in Tertiary schools in 2000 to that in 2002?
Offer a terse response. 0.88. What is the ratio of the Gross enrolment ratio (%) of Pre-primary schools in 2000 to that in 2003?
Your answer should be very brief. 0.96. What is the ratio of the Gross enrolment ratio (%) of Primary schools in 2000 to that in 2003?
Offer a very short reply. 0.99. What is the ratio of the Gross enrolment ratio (%) in Secondary schools in 2000 to that in 2003?
Offer a terse response. 0.99. What is the ratio of the Gross enrolment ratio (%) in Tertiary schools in 2000 to that in 2003?
Keep it short and to the point. 0.87. What is the ratio of the Gross enrolment ratio (%) in Pre-primary schools in 2000 to that in 2004?
Keep it short and to the point. 0.95. What is the ratio of the Gross enrolment ratio (%) of Secondary schools in 2000 to that in 2004?
Your answer should be very brief. 0.99. What is the ratio of the Gross enrolment ratio (%) in Tertiary schools in 2000 to that in 2004?
Your response must be concise. 0.87. What is the ratio of the Gross enrolment ratio (%) of Pre-primary schools in 2000 to that in 2005?
Offer a very short reply. 0.91. What is the ratio of the Gross enrolment ratio (%) in Primary schools in 2000 to that in 2005?
Make the answer very short. 1.02. What is the ratio of the Gross enrolment ratio (%) in Secondary schools in 2000 to that in 2005?
Provide a succinct answer. 0.98. What is the ratio of the Gross enrolment ratio (%) in Tertiary schools in 2000 to that in 2005?
Keep it short and to the point. 0.84. What is the ratio of the Gross enrolment ratio (%) of Pre-primary schools in 2000 to that in 2006?
Your answer should be compact. 0.89. What is the ratio of the Gross enrolment ratio (%) in Primary schools in 2000 to that in 2006?
Your response must be concise. 1.03. What is the ratio of the Gross enrolment ratio (%) in Secondary schools in 2000 to that in 2006?
Offer a very short reply. 1.02. What is the ratio of the Gross enrolment ratio (%) of Tertiary schools in 2000 to that in 2006?
Your answer should be compact. 0.78. What is the ratio of the Gross enrolment ratio (%) in Pre-primary schools in 2000 to that in 2007?
Offer a terse response. 0.92. What is the ratio of the Gross enrolment ratio (%) in Primary schools in 2000 to that in 2007?
Your response must be concise. 1.03. What is the ratio of the Gross enrolment ratio (%) in Secondary schools in 2000 to that in 2007?
Keep it short and to the point. 1.03. What is the ratio of the Gross enrolment ratio (%) in Tertiary schools in 2000 to that in 2007?
Give a very brief answer. 0.77. What is the ratio of the Gross enrolment ratio (%) of Pre-primary schools in 2002 to that in 2003?
Make the answer very short. 1.02. What is the ratio of the Gross enrolment ratio (%) of Secondary schools in 2002 to that in 2003?
Offer a very short reply. 0.99. What is the ratio of the Gross enrolment ratio (%) of Pre-primary schools in 2002 to that in 2004?
Offer a very short reply. 1. What is the ratio of the Gross enrolment ratio (%) of Secondary schools in 2002 to that in 2004?
Your answer should be very brief. 0.99. What is the ratio of the Gross enrolment ratio (%) in Tertiary schools in 2002 to that in 2004?
Make the answer very short. 0.99. What is the ratio of the Gross enrolment ratio (%) of Pre-primary schools in 2002 to that in 2005?
Ensure brevity in your answer.  0.97. What is the ratio of the Gross enrolment ratio (%) of Primary schools in 2002 to that in 2005?
Make the answer very short. 1.03. What is the ratio of the Gross enrolment ratio (%) in Secondary schools in 2002 to that in 2005?
Make the answer very short. 0.98. What is the ratio of the Gross enrolment ratio (%) in Tertiary schools in 2002 to that in 2005?
Your answer should be compact. 0.96. What is the ratio of the Gross enrolment ratio (%) of Pre-primary schools in 2002 to that in 2006?
Provide a short and direct response. 0.94. What is the ratio of the Gross enrolment ratio (%) in Primary schools in 2002 to that in 2006?
Offer a terse response. 1.04. What is the ratio of the Gross enrolment ratio (%) in Secondary schools in 2002 to that in 2006?
Ensure brevity in your answer.  1.02. What is the ratio of the Gross enrolment ratio (%) in Tertiary schools in 2002 to that in 2006?
Keep it short and to the point. 0.89. What is the ratio of the Gross enrolment ratio (%) of Pre-primary schools in 2002 to that in 2007?
Your response must be concise. 0.97. What is the ratio of the Gross enrolment ratio (%) in Primary schools in 2002 to that in 2007?
Keep it short and to the point. 1.05. What is the ratio of the Gross enrolment ratio (%) of Secondary schools in 2002 to that in 2007?
Provide a succinct answer. 1.03. What is the ratio of the Gross enrolment ratio (%) in Tertiary schools in 2002 to that in 2007?
Provide a short and direct response. 0.87. What is the ratio of the Gross enrolment ratio (%) of Pre-primary schools in 2003 to that in 2004?
Give a very brief answer. 0.99. What is the ratio of the Gross enrolment ratio (%) in Primary schools in 2003 to that in 2004?
Offer a very short reply. 1.01. What is the ratio of the Gross enrolment ratio (%) of Secondary schools in 2003 to that in 2004?
Your answer should be very brief. 1. What is the ratio of the Gross enrolment ratio (%) of Tertiary schools in 2003 to that in 2004?
Offer a very short reply. 1. What is the ratio of the Gross enrolment ratio (%) of Pre-primary schools in 2003 to that in 2005?
Provide a short and direct response. 0.95. What is the ratio of the Gross enrolment ratio (%) in Primary schools in 2003 to that in 2005?
Offer a terse response. 1.03. What is the ratio of the Gross enrolment ratio (%) of Secondary schools in 2003 to that in 2005?
Keep it short and to the point. 0.99. What is the ratio of the Gross enrolment ratio (%) of Pre-primary schools in 2003 to that in 2006?
Your answer should be compact. 0.93. What is the ratio of the Gross enrolment ratio (%) in Primary schools in 2003 to that in 2006?
Give a very brief answer. 1.04. What is the ratio of the Gross enrolment ratio (%) in Secondary schools in 2003 to that in 2006?
Your answer should be compact. 1.03. What is the ratio of the Gross enrolment ratio (%) in Tertiary schools in 2003 to that in 2006?
Provide a short and direct response. 0.9. What is the ratio of the Gross enrolment ratio (%) in Pre-primary schools in 2003 to that in 2007?
Offer a very short reply. 0.96. What is the ratio of the Gross enrolment ratio (%) of Primary schools in 2003 to that in 2007?
Your answer should be compact. 1.05. What is the ratio of the Gross enrolment ratio (%) in Secondary schools in 2003 to that in 2007?
Your answer should be very brief. 1.04. What is the ratio of the Gross enrolment ratio (%) of Tertiary schools in 2003 to that in 2007?
Ensure brevity in your answer.  0.88. What is the ratio of the Gross enrolment ratio (%) in Pre-primary schools in 2004 to that in 2005?
Your response must be concise. 0.96. What is the ratio of the Gross enrolment ratio (%) in Primary schools in 2004 to that in 2005?
Keep it short and to the point. 1.02. What is the ratio of the Gross enrolment ratio (%) of Secondary schools in 2004 to that in 2005?
Offer a terse response. 0.99. What is the ratio of the Gross enrolment ratio (%) of Tertiary schools in 2004 to that in 2005?
Ensure brevity in your answer.  0.97. What is the ratio of the Gross enrolment ratio (%) in Pre-primary schools in 2004 to that in 2006?
Offer a very short reply. 0.94. What is the ratio of the Gross enrolment ratio (%) in Primary schools in 2004 to that in 2006?
Ensure brevity in your answer.  1.03. What is the ratio of the Gross enrolment ratio (%) in Secondary schools in 2004 to that in 2006?
Your answer should be compact. 1.03. What is the ratio of the Gross enrolment ratio (%) in Tertiary schools in 2004 to that in 2006?
Offer a terse response. 0.9. What is the ratio of the Gross enrolment ratio (%) of Pre-primary schools in 2004 to that in 2007?
Keep it short and to the point. 0.97. What is the ratio of the Gross enrolment ratio (%) of Primary schools in 2004 to that in 2007?
Give a very brief answer. 1.04. What is the ratio of the Gross enrolment ratio (%) of Secondary schools in 2004 to that in 2007?
Give a very brief answer. 1.04. What is the ratio of the Gross enrolment ratio (%) in Tertiary schools in 2004 to that in 2007?
Your answer should be very brief. 0.88. What is the ratio of the Gross enrolment ratio (%) of Pre-primary schools in 2005 to that in 2006?
Ensure brevity in your answer.  0.97. What is the ratio of the Gross enrolment ratio (%) of Primary schools in 2005 to that in 2006?
Give a very brief answer. 1.01. What is the ratio of the Gross enrolment ratio (%) of Secondary schools in 2005 to that in 2006?
Provide a succinct answer. 1.04. What is the ratio of the Gross enrolment ratio (%) of Tertiary schools in 2005 to that in 2006?
Offer a terse response. 0.93. What is the ratio of the Gross enrolment ratio (%) of Pre-primary schools in 2005 to that in 2007?
Keep it short and to the point. 1.01. What is the ratio of the Gross enrolment ratio (%) in Primary schools in 2005 to that in 2007?
Your answer should be very brief. 1.02. What is the ratio of the Gross enrolment ratio (%) of Secondary schools in 2005 to that in 2007?
Offer a terse response. 1.05. What is the ratio of the Gross enrolment ratio (%) in Tertiary schools in 2005 to that in 2007?
Your response must be concise. 0.91. What is the ratio of the Gross enrolment ratio (%) of Pre-primary schools in 2006 to that in 2007?
Your response must be concise. 1.03. What is the ratio of the Gross enrolment ratio (%) in Primary schools in 2006 to that in 2007?
Provide a short and direct response. 1.01. What is the ratio of the Gross enrolment ratio (%) in Secondary schools in 2006 to that in 2007?
Ensure brevity in your answer.  1.01. What is the ratio of the Gross enrolment ratio (%) of Tertiary schools in 2006 to that in 2007?
Your answer should be compact. 0.98. What is the difference between the highest and the second highest Gross enrolment ratio (%) of Pre-primary schools?
Keep it short and to the point. 0.89. What is the difference between the highest and the second highest Gross enrolment ratio (%) of Primary schools?
Your response must be concise. 0.13. What is the difference between the highest and the second highest Gross enrolment ratio (%) in Secondary schools?
Offer a terse response. 1.07. What is the difference between the highest and the second highest Gross enrolment ratio (%) in Tertiary schools?
Ensure brevity in your answer.  0.82. What is the difference between the highest and the lowest Gross enrolment ratio (%) in Pre-primary schools?
Your response must be concise. 3.84. What is the difference between the highest and the lowest Gross enrolment ratio (%) in Primary schools?
Make the answer very short. 4.79. What is the difference between the highest and the lowest Gross enrolment ratio (%) of Secondary schools?
Offer a very short reply. 4.83. What is the difference between the highest and the lowest Gross enrolment ratio (%) of Tertiary schools?
Make the answer very short. 10.43. 